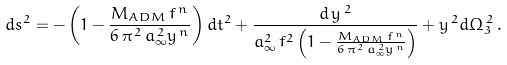<formula> <loc_0><loc_0><loc_500><loc_500>d s ^ { 2 } = - \left ( 1 - \frac { M _ { A D M } \, f ^ { \, n } } { 6 \, \pi ^ { \, 2 } \, a _ { \infty } ^ { \, 2 } y ^ { \, n } } \right ) d t ^ { 2 } + \frac { d \, y ^ { \, 2 } } { a _ { \infty } ^ { 2 } \, f ^ { 2 } \left ( 1 - \frac { M _ { A D M } \, f ^ { \, n } } { 6 \, \pi ^ { \, 2 } \, a _ { \infty } ^ { \, 2 } y ^ { \, n } } \right ) } + y ^ { \, 2 } d \Omega _ { 3 } ^ { \, 2 } \, .</formula> 